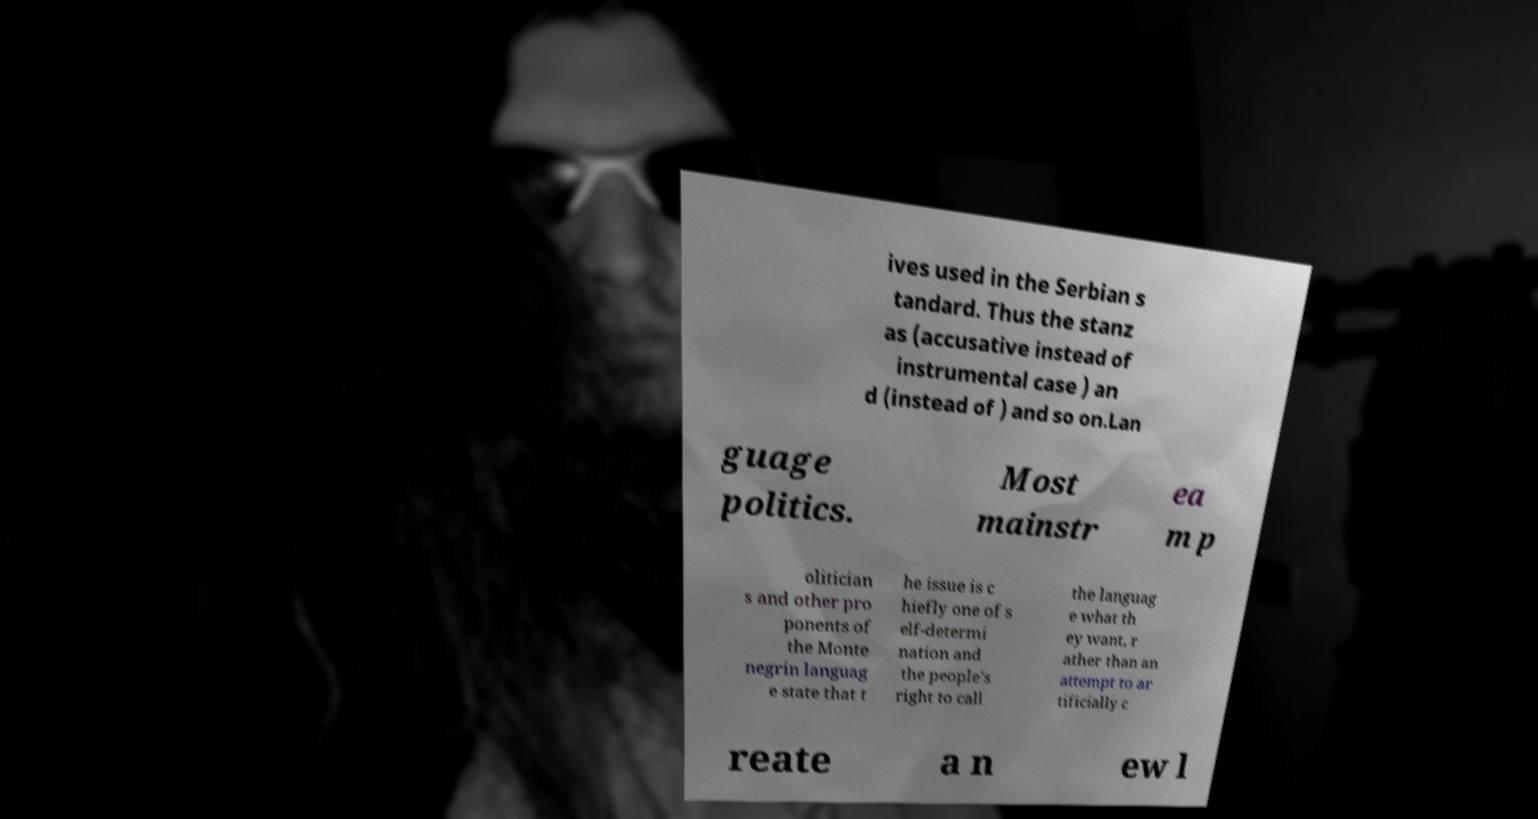Can you accurately transcribe the text from the provided image for me? ives used in the Serbian s tandard. Thus the stanz as (accusative instead of instrumental case ) an d (instead of ) and so on.Lan guage politics. Most mainstr ea m p olitician s and other pro ponents of the Monte negrin languag e state that t he issue is c hiefly one of s elf-determi nation and the people's right to call the languag e what th ey want, r ather than an attempt to ar tificially c reate a n ew l 